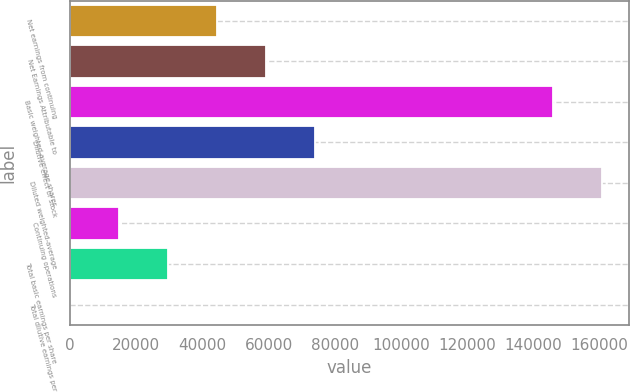Convert chart. <chart><loc_0><loc_0><loc_500><loc_500><bar_chart><fcel>Net earnings from continuing<fcel>Net Earnings Attributable to<fcel>Basic weighted-average shares<fcel>Dilutive effect of stock<fcel>Diluted weighted-average<fcel>Continuing operations<fcel>Total basic earnings per share<fcel>Total dilutive earnings per<nl><fcel>44466.7<fcel>59286.7<fcel>146041<fcel>74106.8<fcel>160861<fcel>14826.6<fcel>29646.6<fcel>6.51<nl></chart> 